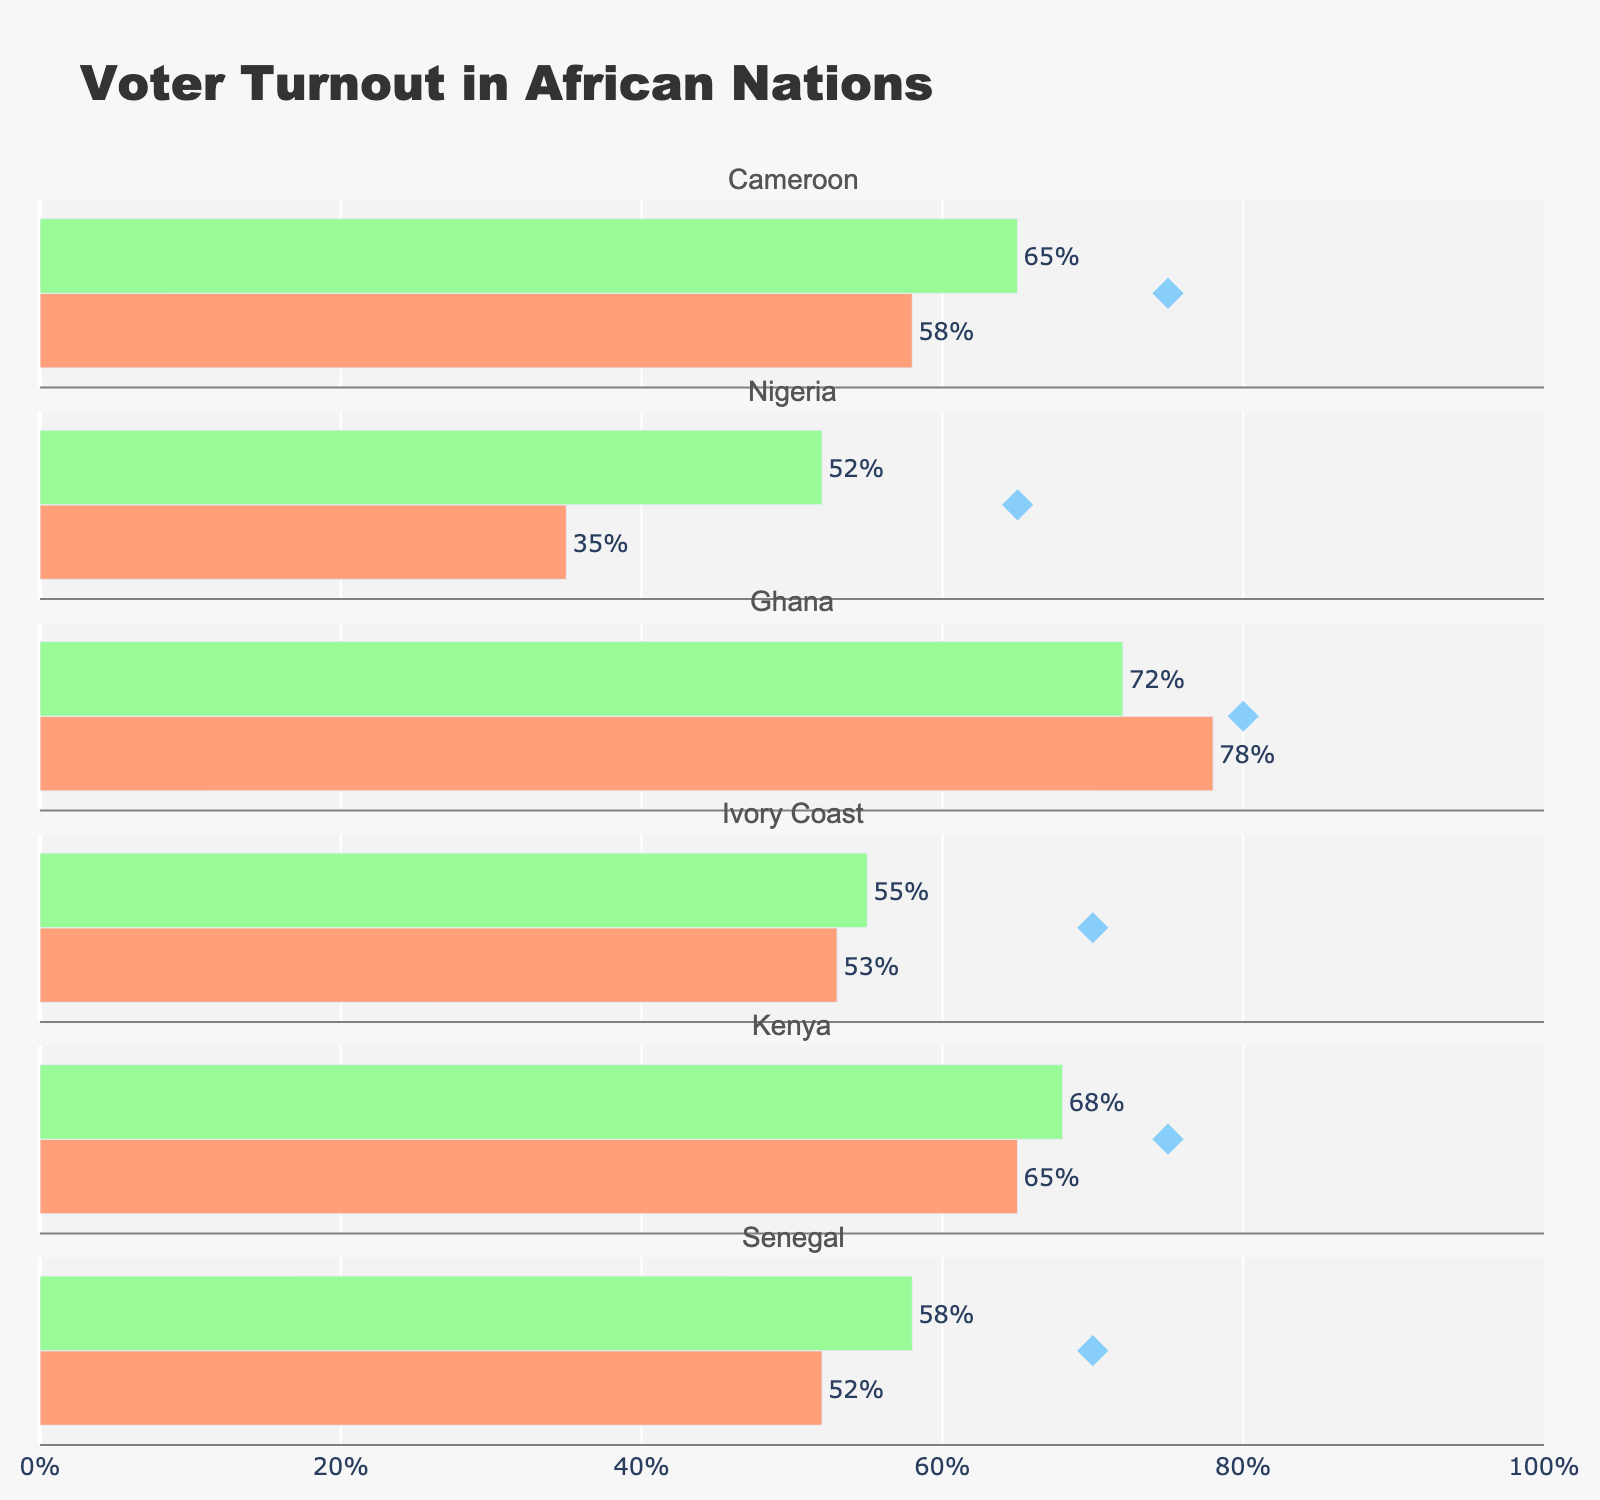What is the title of the figure? The title is prominently displayed at the top of the figure, indicating the main subject or theme of the data presented.
Answer: Voter Turnout in African Nations What is the average turnout for Ghana? Locate the row for Ghana and identify the value corresponding to the average turnout bar, represented in green.
Answer: 72% Which country has the highest actual turnout? Compare the actual turnout values (red bars) for all the countries to find the highest one. Ghana's actual turnout of 78% is the highest among them.
Answer: Ghana How does Cameroon's actual turnout compare to its target turnout? Look at Cameroon's values for actual turnout and target turnout. The actual turnout is 58% compared to a target of 75%, showing a shortfall.
Answer: 17% below target Which country’s average turnout is closest to its target turnout? Calculate the differences between the average and target turnouts for each country and identify the smallest difference. Ghana’s average turnout is 72% and the target is 80%, which is an 8% difference, the smallest difference.
Answer: Ghana How many countries have an actual turnout that is lower than their average turnout? Count the number of countries where the actual turnout (red bar) is less than the average turnout (green bar). Cameroon, Nigeria, Ivory Coast, and Senegal, all show lower actual turnout than their average.
Answer: 4 Is Cameroon's actual turnout above or below the average turnout of 65%? Identify Cameroon's actual turnout bar and compare it with the average turnout listed. Cameroon's actual turnout is 58%, which is below the average.
Answer: Below Which country has the largest gap between its actual turnout and target turnout? For all countries, calculate the difference between the actual and target turnouts, then identify the largest difference. Nigeria's difference of 30% (35% actual vs. 65% target) is the highest.
Answer: Nigeria What's the difference between the actual turnout of Kenya and its average turnout? Subtract the actual turnout of Kenya (65%) from its average turnout (68%) to find the difference. The difference is 3%.
Answer: 3% How much lower is Senegal's actual turnout compared to Cameroon's actual turnout? Compare Senegal's actual turnout (52%) to Cameroon's (58%) by subtracting Senegal's from Cameroon's. The result is 6%.
Answer: 6% lower 